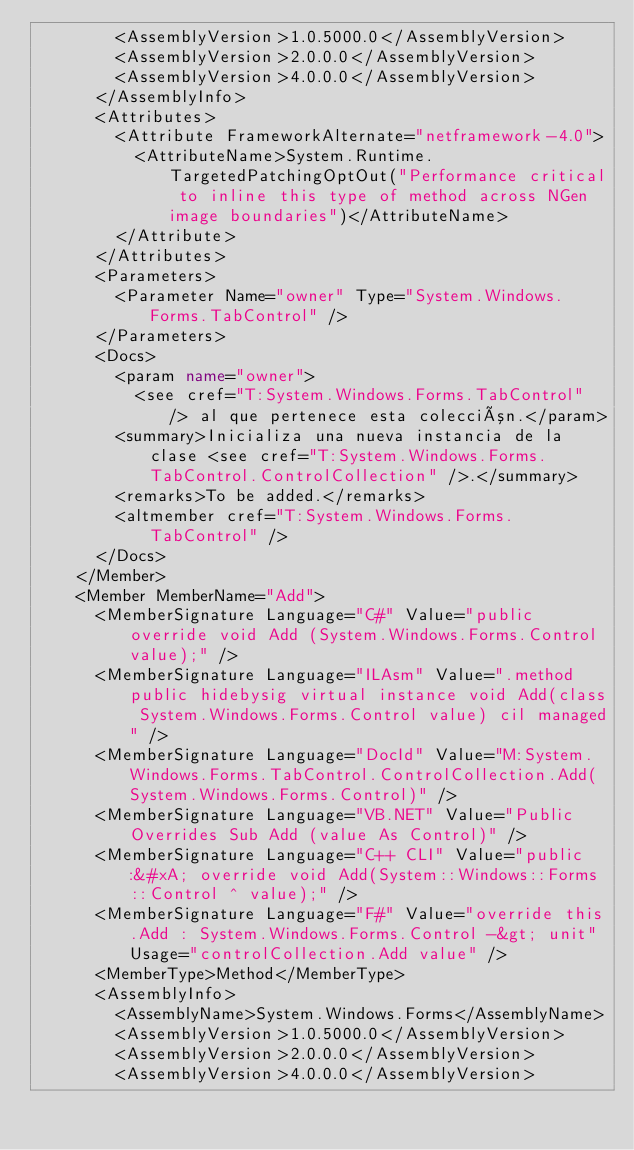Convert code to text. <code><loc_0><loc_0><loc_500><loc_500><_XML_>        <AssemblyVersion>1.0.5000.0</AssemblyVersion>
        <AssemblyVersion>2.0.0.0</AssemblyVersion>
        <AssemblyVersion>4.0.0.0</AssemblyVersion>
      </AssemblyInfo>
      <Attributes>
        <Attribute FrameworkAlternate="netframework-4.0">
          <AttributeName>System.Runtime.TargetedPatchingOptOut("Performance critical to inline this type of method across NGen image boundaries")</AttributeName>
        </Attribute>
      </Attributes>
      <Parameters>
        <Parameter Name="owner" Type="System.Windows.Forms.TabControl" />
      </Parameters>
      <Docs>
        <param name="owner">
          <see cref="T:System.Windows.Forms.TabControl" /> al que pertenece esta colección.</param>
        <summary>Inicializa una nueva instancia de la clase <see cref="T:System.Windows.Forms.TabControl.ControlCollection" />.</summary>
        <remarks>To be added.</remarks>
        <altmember cref="T:System.Windows.Forms.TabControl" />
      </Docs>
    </Member>
    <Member MemberName="Add">
      <MemberSignature Language="C#" Value="public override void Add (System.Windows.Forms.Control value);" />
      <MemberSignature Language="ILAsm" Value=".method public hidebysig virtual instance void Add(class System.Windows.Forms.Control value) cil managed" />
      <MemberSignature Language="DocId" Value="M:System.Windows.Forms.TabControl.ControlCollection.Add(System.Windows.Forms.Control)" />
      <MemberSignature Language="VB.NET" Value="Public Overrides Sub Add (value As Control)" />
      <MemberSignature Language="C++ CLI" Value="public:&#xA; override void Add(System::Windows::Forms::Control ^ value);" />
      <MemberSignature Language="F#" Value="override this.Add : System.Windows.Forms.Control -&gt; unit" Usage="controlCollection.Add value" />
      <MemberType>Method</MemberType>
      <AssemblyInfo>
        <AssemblyName>System.Windows.Forms</AssemblyName>
        <AssemblyVersion>1.0.5000.0</AssemblyVersion>
        <AssemblyVersion>2.0.0.0</AssemblyVersion>
        <AssemblyVersion>4.0.0.0</AssemblyVersion></code> 